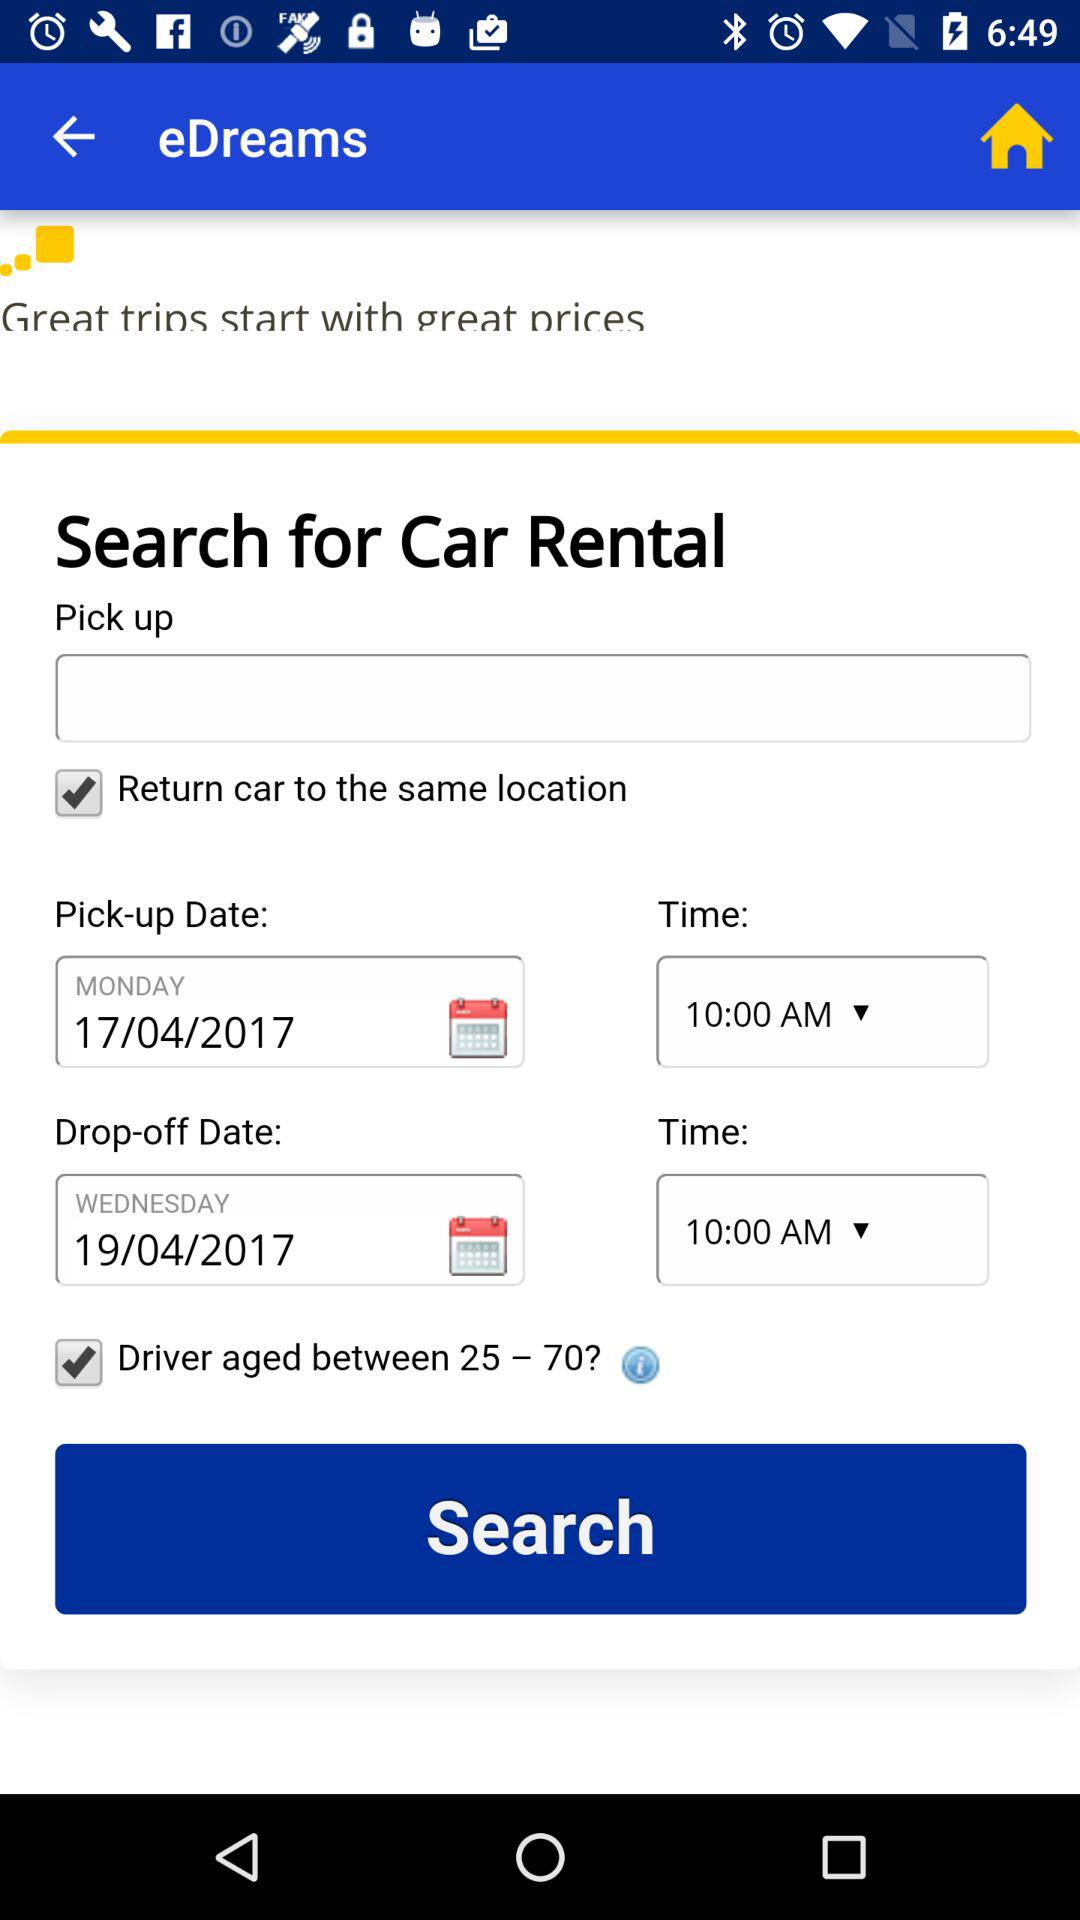What is the age range for the driver? The age range is from 25 to 70 years. 